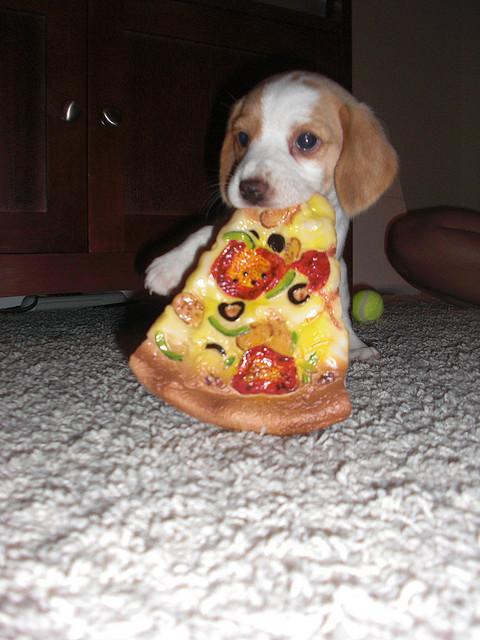Is this a typical food for this animal?
Short answer required. No. What are the dogs laying on?
Quick response, please. Carpet. Is that a basketball in the background?
Keep it brief. No. What type of breed is this dog?
Short answer required. Beagle. What is this puppy doing?
Short answer required. Playing. What breed of puppy is it?
Write a very short answer. Beagle. What is the dog chewing on?
Give a very brief answer. Pizza. What color is the door?
Concise answer only. Brown. What is the puppy chewing on?
Quick response, please. Pizza. How old is the dog?
Quick response, please. Puppy. Is the dog's tongue out?
Short answer required. No. What color is the floor?
Concise answer only. White. What color is the dog?
Quick response, please. Brown and white. Is the floor wooden?
Concise answer only. No. What is the dog celebrating?
Keep it brief. Birthday. 